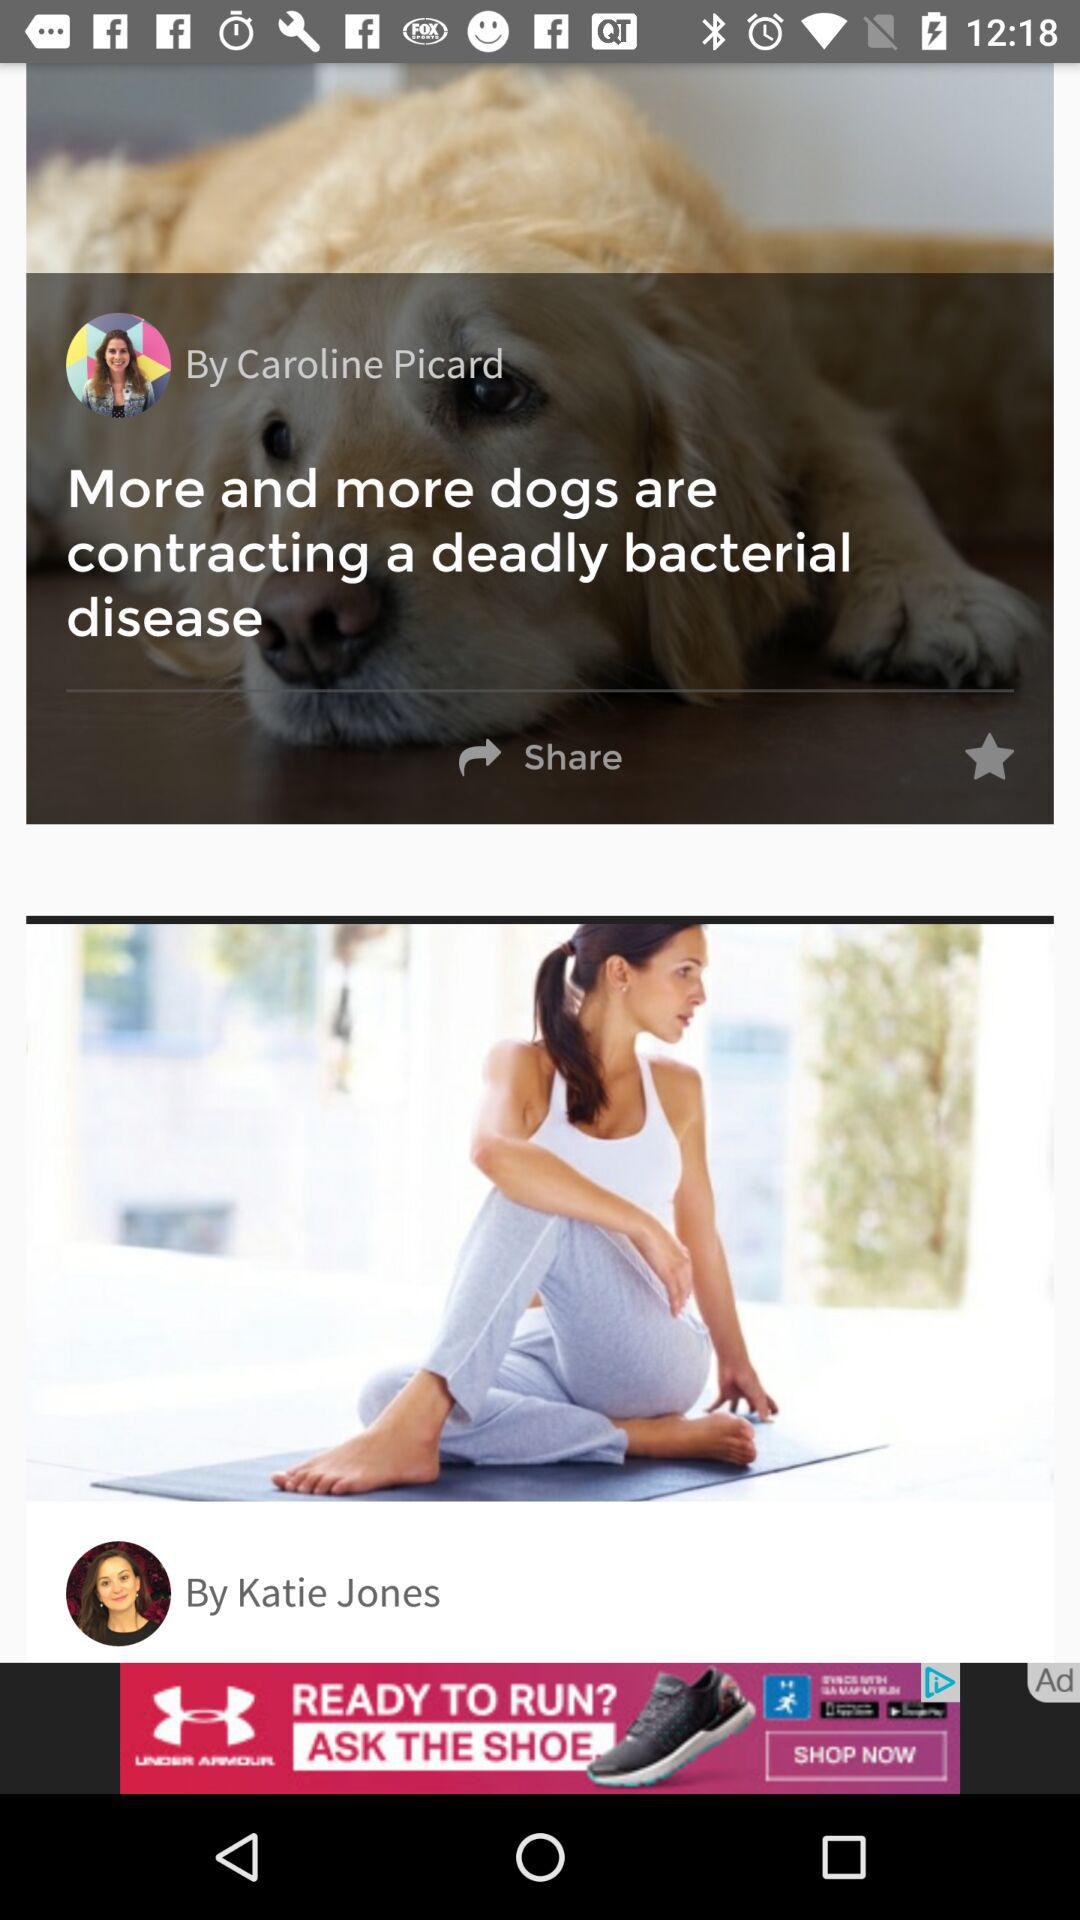Who posted the article "More and more dogs are contracting a deadly bacterial disease"? The article "More and more dogs are contracting a deadly bacterial disease" was posted by Caroline Picard. 